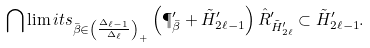Convert formula to latex. <formula><loc_0><loc_0><loc_500><loc_500>\bigcap \lim i t s _ { \bar { \beta } \in \left ( \frac { \Delta _ { \ell - 1 } } { \Delta _ { \ell } } \right ) _ { + } } \left ( \P ^ { \prime } _ { \bar { \beta } } + \tilde { H } ^ { \prime } _ { 2 \ell - 1 } \right ) \hat { R } ^ { \prime } _ { \tilde { H } ^ { \prime } _ { 2 \ell } } \subset \tilde { H } ^ { \prime } _ { 2 \ell - 1 } .</formula> 